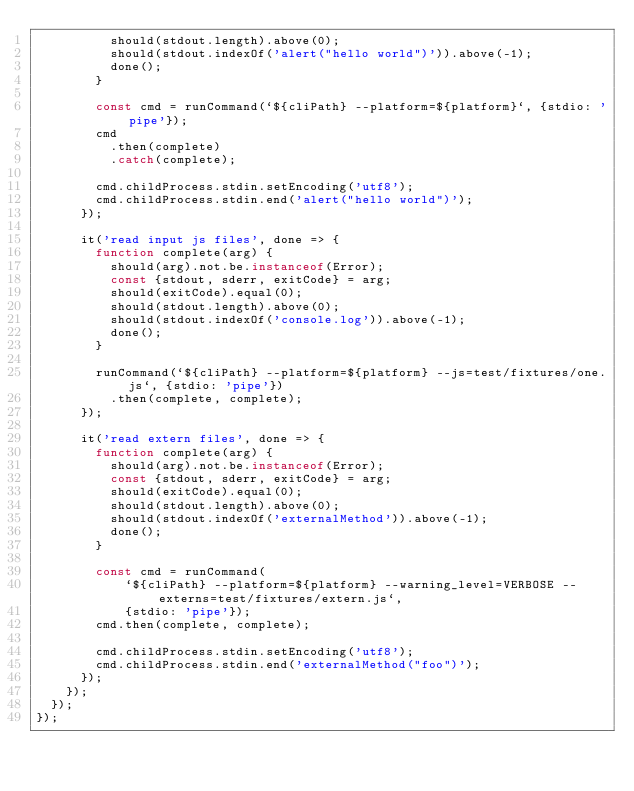Convert code to text. <code><loc_0><loc_0><loc_500><loc_500><_JavaScript_>          should(stdout.length).above(0);
          should(stdout.indexOf('alert("hello world")')).above(-1);
          done();
        }

        const cmd = runCommand(`${cliPath} --platform=${platform}`, {stdio: 'pipe'});
        cmd
          .then(complete)
          .catch(complete);

        cmd.childProcess.stdin.setEncoding('utf8');
        cmd.childProcess.stdin.end('alert("hello world")');
      });

      it('read input js files', done => {
        function complete(arg) {
          should(arg).not.be.instanceof(Error);
          const {stdout, sderr, exitCode} = arg;
          should(exitCode).equal(0);
          should(stdout.length).above(0);
          should(stdout.indexOf('console.log')).above(-1);
          done();
        }

        runCommand(`${cliPath} --platform=${platform} --js=test/fixtures/one.js`, {stdio: 'pipe'})
          .then(complete, complete);
      });

      it('read extern files', done => {
        function complete(arg) {
          should(arg).not.be.instanceof(Error);
          const {stdout, sderr, exitCode} = arg;
          should(exitCode).equal(0);
          should(stdout.length).above(0);
          should(stdout.indexOf('externalMethod')).above(-1);
          done();
        }

        const cmd = runCommand(
            `${cliPath} --platform=${platform} --warning_level=VERBOSE --externs=test/fixtures/extern.js`,
            {stdio: 'pipe'});
        cmd.then(complete, complete);

        cmd.childProcess.stdin.setEncoding('utf8');
        cmd.childProcess.stdin.end('externalMethod("foo")');
      });
    });
  });
});
</code> 